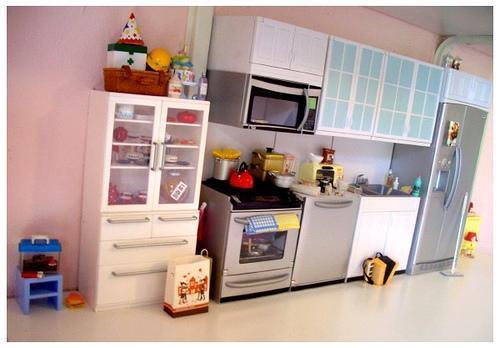How many stove in the kitchen?
Give a very brief answer. 1. 